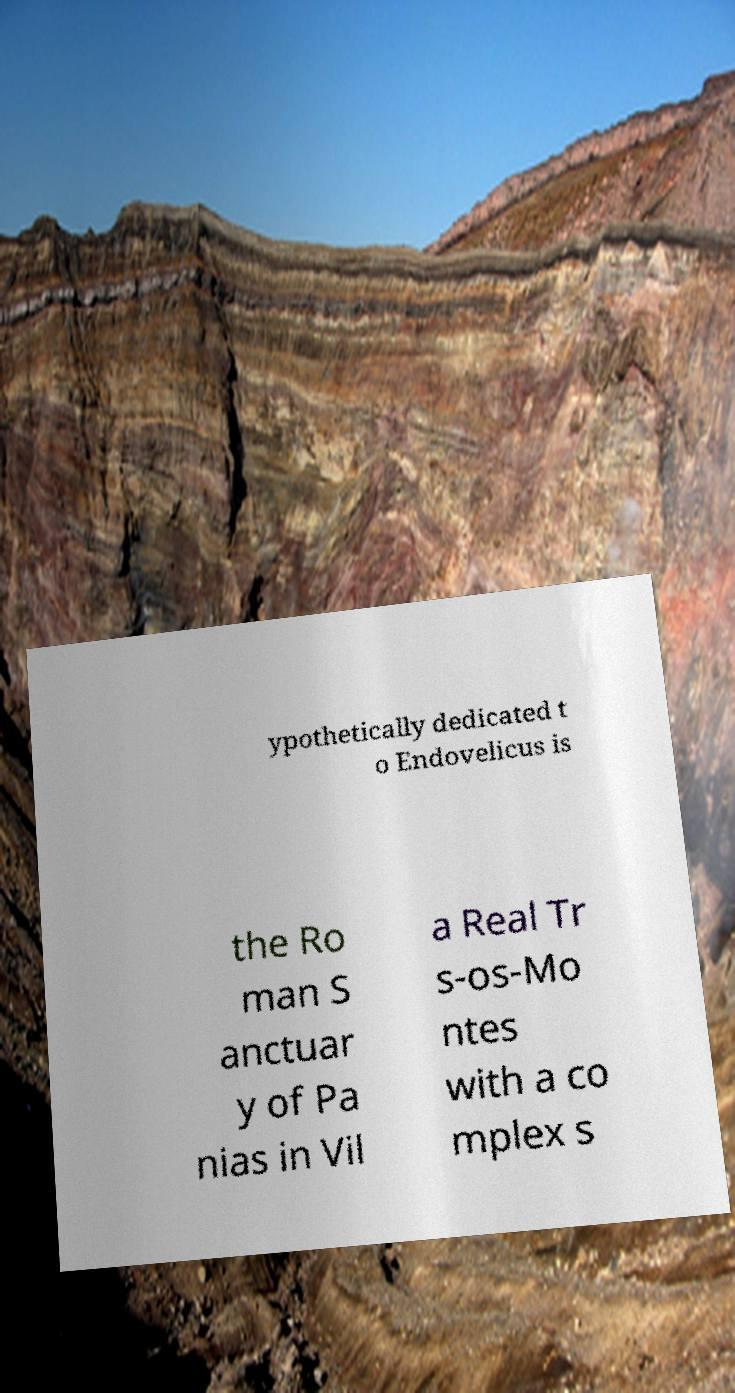Could you assist in decoding the text presented in this image and type it out clearly? ypothetically dedicated t o Endovelicus is the Ro man S anctuar y of Pa nias in Vil a Real Tr s-os-Mo ntes with a co mplex s 